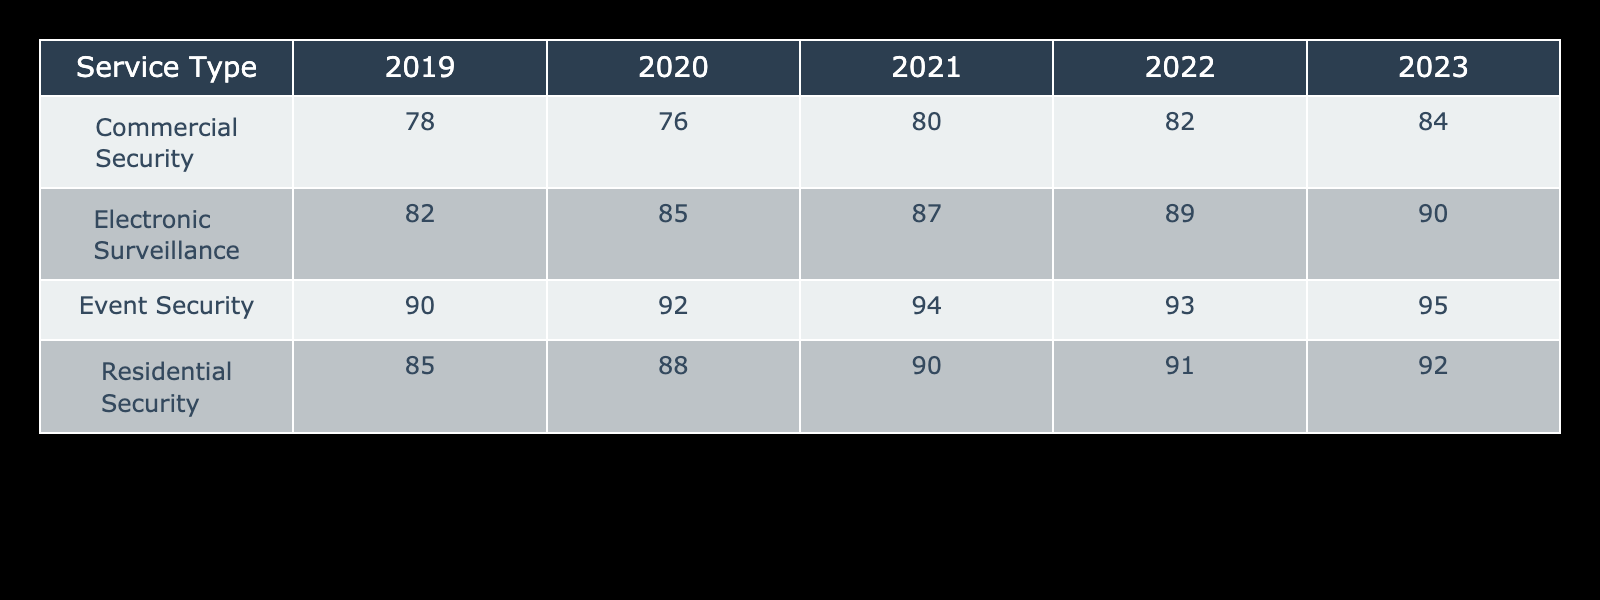What was the client retention rate for Event Security in 2021? In the table, I can find the row for Event Security and then look under the column for the year 2021. The retention rate listed there is 94%.
Answer: 94% Which service type had the highest client retention rate in 2020? I will look through the 2020 column for all service types and find the maximum value. The highest value is 92%, which corresponds to Event Security.
Answer: Event Security What is the average client retention rate for Residential Security over all years? I will first sum the retention rates for Residential Security: 85 + 88 + 90 + 91 + 92 = 446. Then, I divide by the total number of years, which is 5, to get an average of 446 / 5 = 89.2.
Answer: 89.2 Did the client retention rate for Commercial Security improve from 2021 to 2023? I will check the rates for Commercial Security in both the 2021 column (80%) and the 2023 column (84%). Since 84% is higher than 80%, the retention rate did improve.
Answer: Yes What was the difference in client retention rate for Electronic Surveillance from 2019 to 2022? The retention rate for Electronic Surveillance in 2019 is 82% and in 2022 it is 89%. The difference is 89 - 82 = 7%.
Answer: 7% Which service type had a consistent increase in retention rate from 2019 to 2023? I will check each service type for an increase in retention rates year over year starting from 2019 up to 2023. Residential Security has the following rates: 85%, 88%, 90%, 91%, 92%, and consistently increases.
Answer: Residential Security What was the lowest client retention rate across all years for any service type? I need to check each service type across all years to find the lowest value. The lowest retention rate is 76%, which corresponds to Commercial Security in the year 2020.
Answer: 76% In which year did Event Security have its highest client retention rate? Looking at the Event Security values for each year, they are: 90% (2019), 92% (2020), 94% (2021), 93% (2022), and 95% (2023). The highest rate is 95%, which is in 2023.
Answer: 2023 